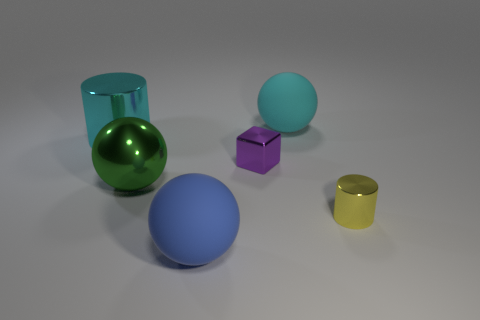Add 4 shiny cylinders. How many objects exist? 10 Subtract all blocks. How many objects are left? 5 Add 6 large blue objects. How many large blue objects are left? 7 Add 6 big green metal spheres. How many big green metal spheres exist? 7 Subtract 0 gray blocks. How many objects are left? 6 Subtract all tiny purple matte cylinders. Subtract all small purple metallic objects. How many objects are left? 5 